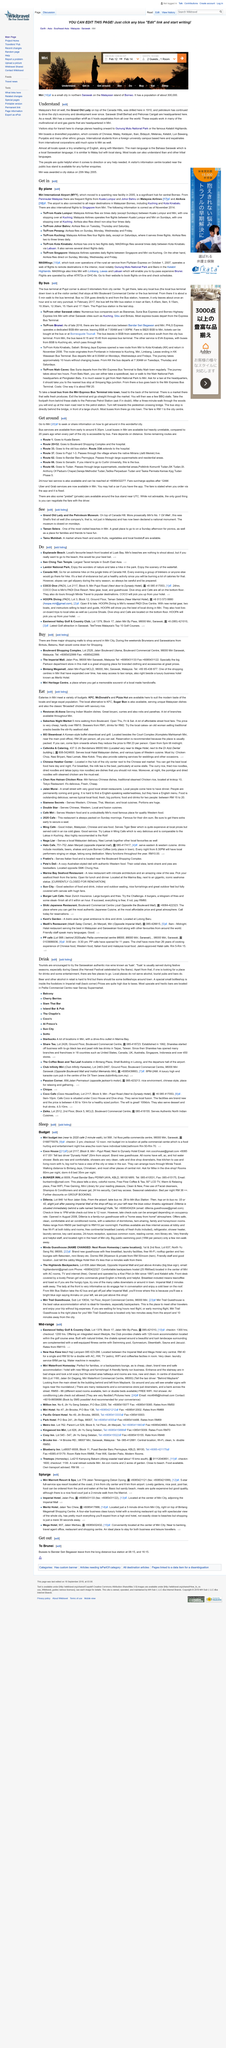Outline some significant characteristics in this image. Visitors to Miri may choose to stop en route to Gunung Mulu National Park or the Kelabit Highlands, as a layover destination or as a final destination. In Miri, the main language spoken is the Bahasa Sarawak, which is similar to Malay, but with local slang, and is spoken by almost all locals. Many also speak English and Mandarin, and can understand Iban and other tribal languages. Miri's economy and development have been largely driven by the oil industry, with Sarawak Shell Berhad and Petronas Carigali both headquartered in the city. 